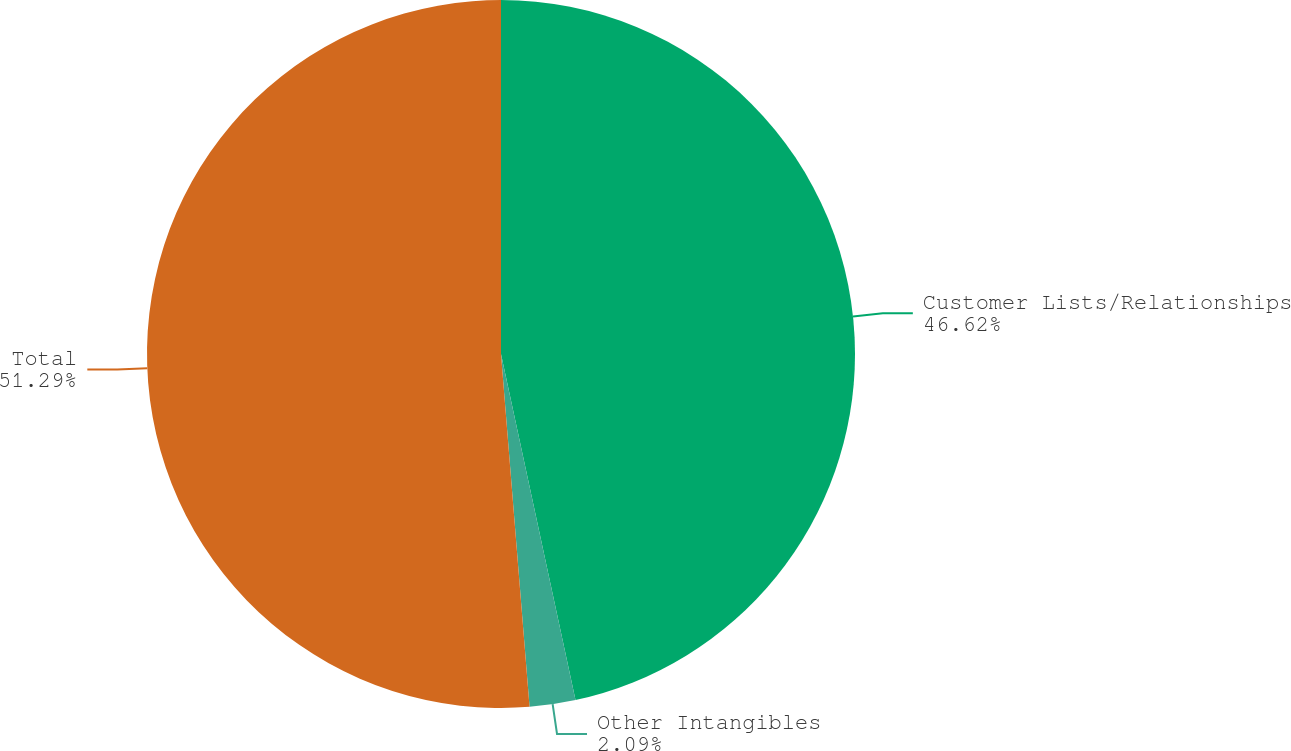<chart> <loc_0><loc_0><loc_500><loc_500><pie_chart><fcel>Customer Lists/Relationships<fcel>Other Intangibles<fcel>Total<nl><fcel>46.62%<fcel>2.09%<fcel>51.28%<nl></chart> 